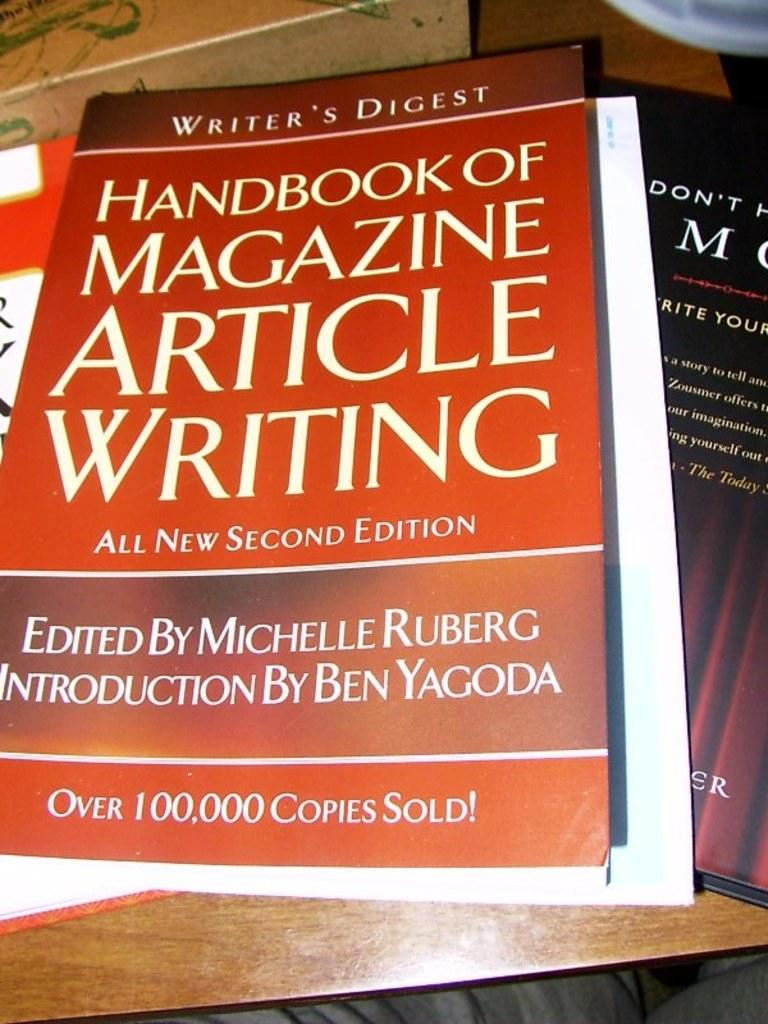<image>
Offer a succinct explanation of the picture presented. The table is stacked with several books, including the "Handbook of Magazine Article Writing". 